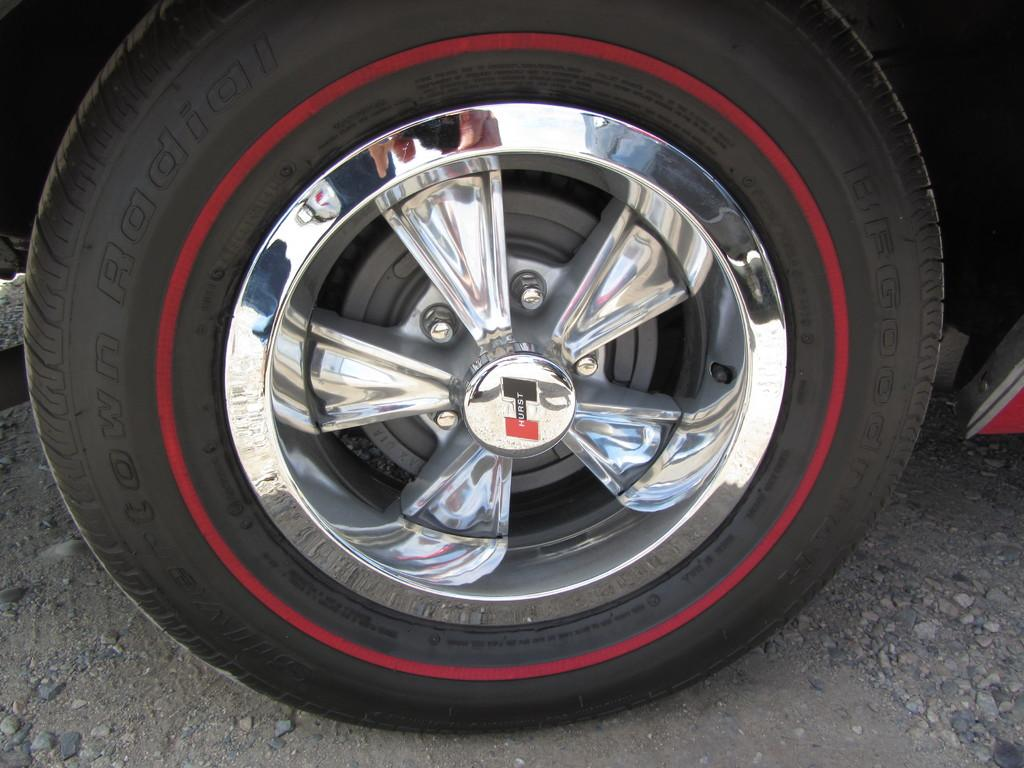What is the main subject in the center of the image? There is a wheel in the center of the image. What can be seen at the bottom of the image? The ground is visible at the bottom of the image. How many cats are sitting on the wheel in the image? There are no cats present in the image; it only features a wheel and the ground. 